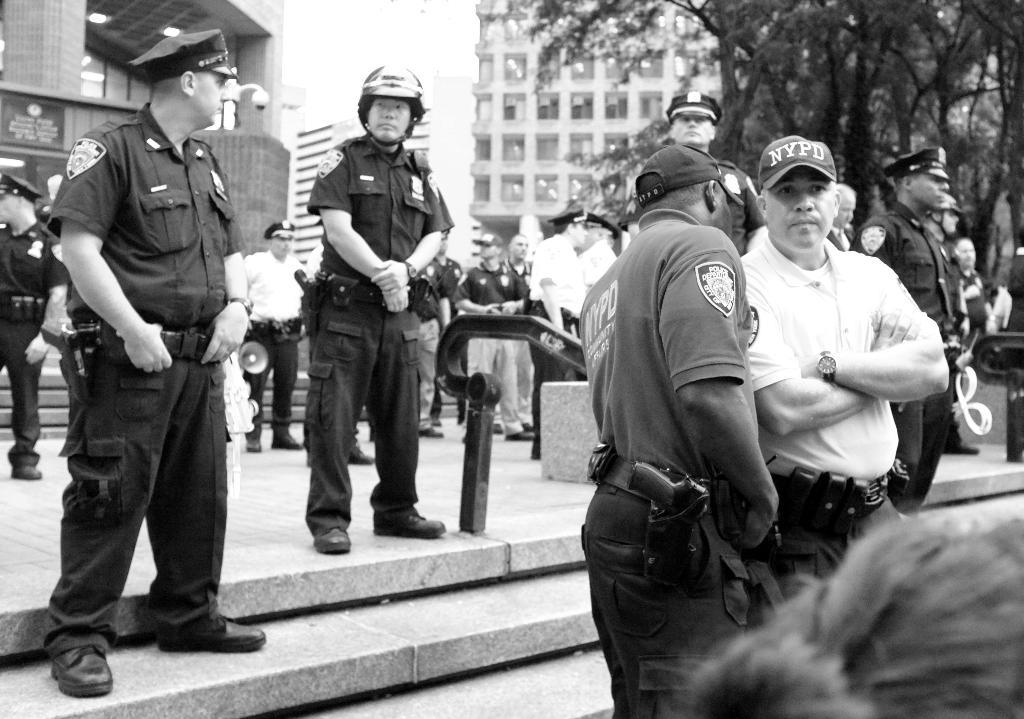What is the color scheme of the image? The image is black and white. What can be seen in the image besides the color scheme? There are people standing in the image, and they are standing on the floor. What else is present in the image? There are buildings, street poles, trees, and the sky visible in the image. Where is the throne located in the image? There is no throne present in the image. What type of finger can be seen pointing at the buildings in the image? There are no fingers pointing at the buildings in the image. 